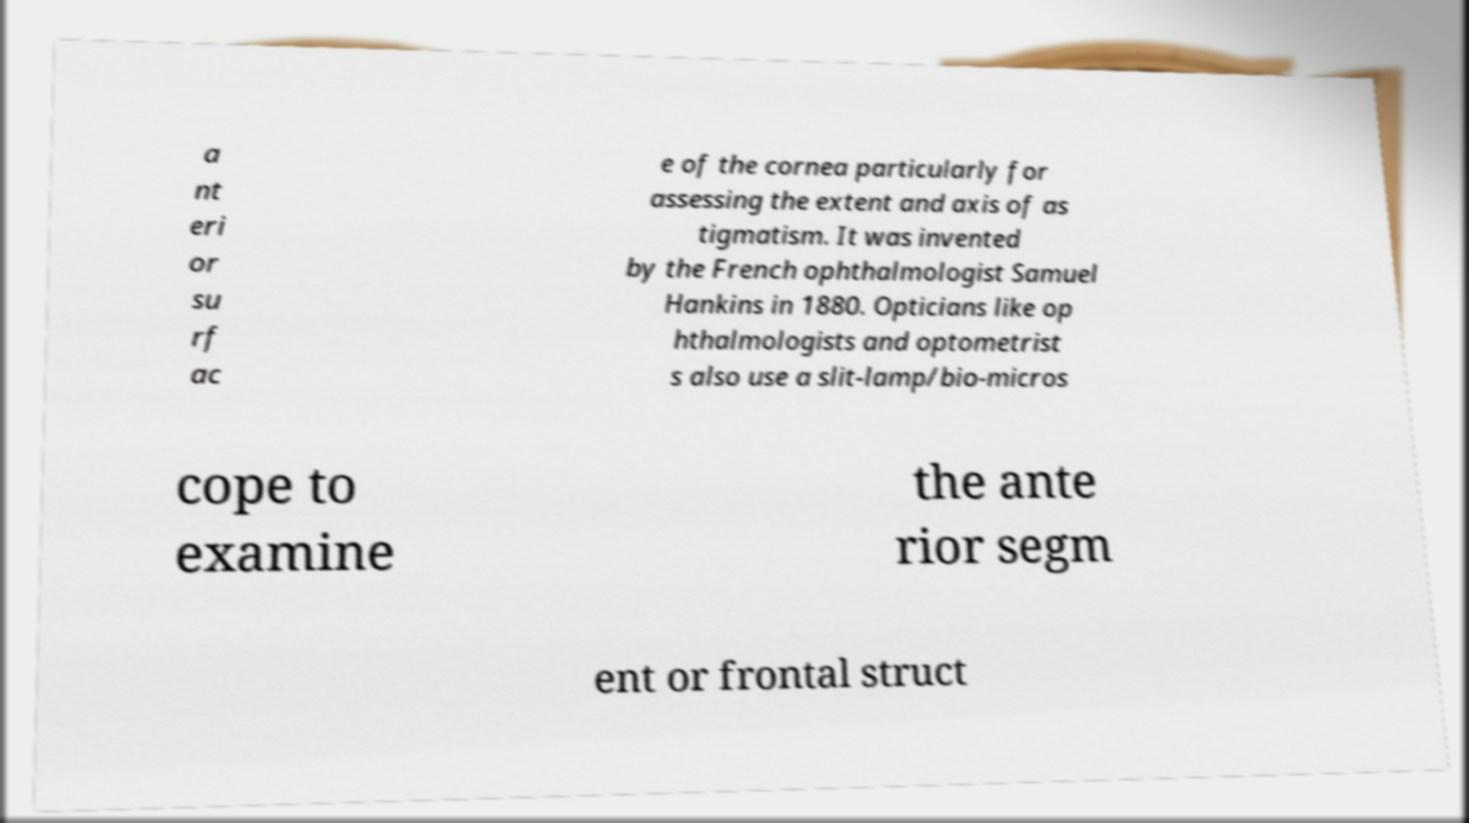Can you read and provide the text displayed in the image?This photo seems to have some interesting text. Can you extract and type it out for me? a nt eri or su rf ac e of the cornea particularly for assessing the extent and axis of as tigmatism. It was invented by the French ophthalmologist Samuel Hankins in 1880. Opticians like op hthalmologists and optometrist s also use a slit-lamp/bio-micros cope to examine the ante rior segm ent or frontal struct 